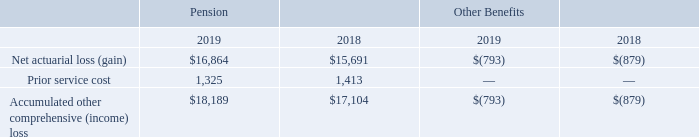Amounts recognized in Accumulated other comprehensive income (loss) at March 31, 2019 and 2018 consist of the following (amounts in thousands):
Although not reflected in the table above, the tax effect on the pension balances was $2.4 million and $2.3 million as of March 31, 2019 and 2018, respectively.
Which years does the table provide information for Amounts recognized in Accumulated other comprehensive income (loss)? 2019, 2018. What was the prior service cost for Pension in 2019?
Answer scale should be: thousand. 1,325. What was the Net actuarial loss (gain) for Other Benefits in 2018?
Answer scale should be: thousand. (879). What was the change in the Net actuarial loss  for Other Benefits between 2018 and 2019? -793-(-879)
Answer: 86. What was the change in the Accumulated other comprehensive (income) loss for Pension between 2018 and 2019?
Answer scale should be: thousand. 18,189-17,104
Answer: 1085. What was the percentage change in the prior service cost for Pension between 2018 and 2019?
Answer scale should be: percent. (1,325-1,413)/1,413
Answer: -6.23. 